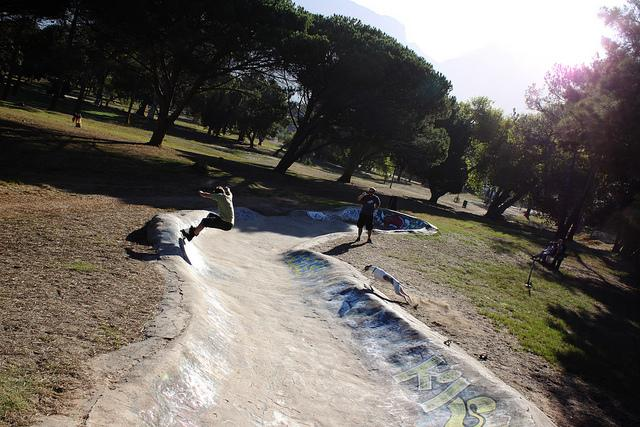Which person could be attacked by the dog first? Please explain your reasoning. green shirt. The person in the green shirt is closest to the dog. 